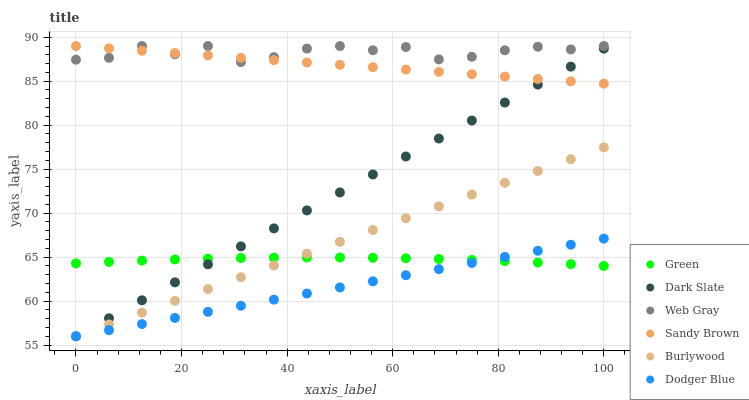Does Dodger Blue have the minimum area under the curve?
Answer yes or no. Yes. Does Web Gray have the maximum area under the curve?
Answer yes or no. Yes. Does Burlywood have the minimum area under the curve?
Answer yes or no. No. Does Burlywood have the maximum area under the curve?
Answer yes or no. No. Is Dodger Blue the smoothest?
Answer yes or no. Yes. Is Web Gray the roughest?
Answer yes or no. Yes. Is Burlywood the smoothest?
Answer yes or no. No. Is Burlywood the roughest?
Answer yes or no. No. Does Burlywood have the lowest value?
Answer yes or no. Yes. Does Green have the lowest value?
Answer yes or no. No. Does Sandy Brown have the highest value?
Answer yes or no. Yes. Does Burlywood have the highest value?
Answer yes or no. No. Is Burlywood less than Web Gray?
Answer yes or no. Yes. Is Sandy Brown greater than Burlywood?
Answer yes or no. Yes. Does Dodger Blue intersect Burlywood?
Answer yes or no. Yes. Is Dodger Blue less than Burlywood?
Answer yes or no. No. Is Dodger Blue greater than Burlywood?
Answer yes or no. No. Does Burlywood intersect Web Gray?
Answer yes or no. No. 